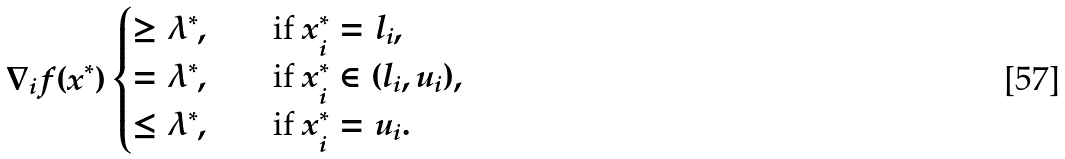Convert formula to latex. <formula><loc_0><loc_0><loc_500><loc_500>\nabla _ { i } f ( x ^ { * } ) \begin{cases} \geq \lambda ^ { * } , \quad & \text {if } x ^ { * } _ { i } = l _ { i } , \\ = \lambda ^ { * } , \quad & \text {if } x ^ { * } _ { i } \in ( l _ { i } , u _ { i } ) , \\ \leq \lambda ^ { * } , \quad & \text {if } x ^ { * } _ { i } = u _ { i } . \end{cases}</formula> 